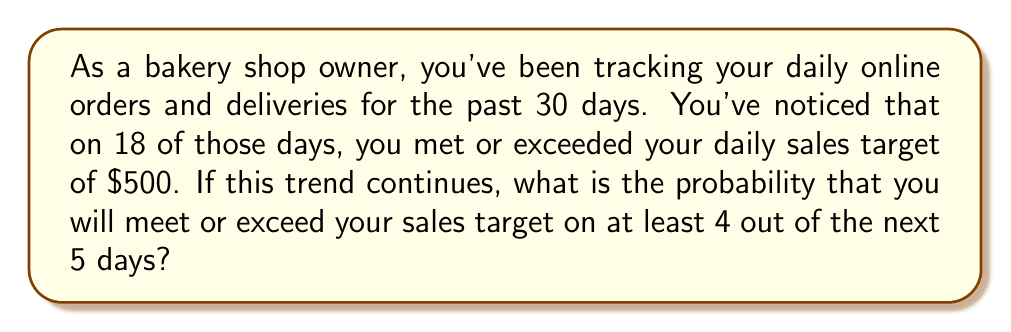Teach me how to tackle this problem. To solve this problem, we'll use the binomial probability distribution. Let's break it down step-by-step:

1. First, we need to calculate the probability of meeting or exceeding the sales target on a single day:
   $p = \frac{18}{30} = 0.6$ or 60%

2. The probability of not meeting the target on a single day is:
   $q = 1 - p = 1 - 0.6 = 0.4$ or 40%

3. We want to find the probability of meeting the target on at least 4 out of 5 days. This means we need to calculate the probability of meeting the target on 4 days OR 5 days.

4. Let's use the binomial probability formula:
   $$P(X = k) = \binom{n}{k} p^k (1-p)^{n-k}$$
   Where:
   $n$ = number of trials (5 days)
   $k$ = number of successes
   $p$ = probability of success on a single trial (0.6)

5. Calculate the probability for 4 successes:
   $$P(X = 4) = \binom{5}{4} (0.6)^4 (0.4)^1 = 5 \cdot 0.1296 \cdot 0.4 = 0.2592$$

6. Calculate the probability for 5 successes:
   $$P(X = 5) = \binom{5}{5} (0.6)^5 (0.4)^0 = 1 \cdot 0.07776 \cdot 1 = 0.07776$$

7. Sum these probabilities to get the probability of at least 4 successes:
   $$P(X \geq 4) = P(X = 4) + P(X = 5) = 0.2592 + 0.07776 = 0.33696$$

Therefore, the probability of meeting or exceeding the sales target on at least 4 out of the next 5 days is approximately 0.33696 or 33.696%.
Answer: The probability of meeting or exceeding the daily sales target on at least 4 out of the next 5 days is approximately 0.33696 or 33.696%. 